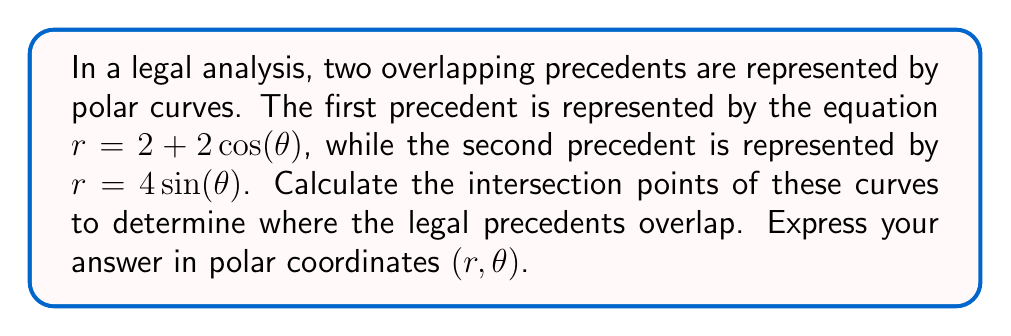Help me with this question. To find the intersection points of these polar curves, we need to solve the system of equations:

$$r = 2 + 2\cos(\theta)$$
$$r = 4\sin(\theta)$$

Step 1: Set the equations equal to each other
$2 + 2\cos(\theta) = 4\sin(\theta)$

Step 2: Rearrange the equation
$2\cos(\theta) - 4\sin(\theta) = -2$

Step 3: Divide both sides by 2
$\cos(\theta) - 2\sin(\theta) = -1$

Step 4: Use the identity $\sin^2(\theta) + \cos^2(\theta) = 1$ to solve for $\sin(\theta)$ and $\cos(\theta)$

Let $\sin(\theta) = x$ and $\cos(\theta) = y$. Then our equation becomes:
$y - 2x = -1$ and $x^2 + y^2 = 1$

Step 5: Solve for y in terms of x
$y = 2x - 1$

Step 6: Substitute this into $x^2 + y^2 = 1$
$x^2 + (2x - 1)^2 = 1$

Step 7: Expand and simplify
$x^2 + 4x^2 - 4x + 1 = 1$
$5x^2 - 4x = 0$
$x(5x - 4) = 0$

Step 8: Solve for x
$x = 0$ or $x = \frac{4}{5}$

Step 9: Find corresponding y values
For $x = 0$: $y = -1$
For $x = \frac{4}{5}$: $y = \frac{3}{5}$

Step 10: Convert back to $\theta$ values
$\theta_1 = \arctan(\frac{0}{-1}) + \pi = \pi$
$\theta_2 = \arctan(\frac{4/5}{3/5}) = \arctan(\frac{4}{3}) \approx 0.9273$ radians

Step 11: Calculate r values
For $\theta_1 = \pi$: $r = 2 + 2\cos(\pi) = 0$
For $\theta_2 \approx 0.9273$: $r = 4\sin(0.9273) \approx 3.2$

Therefore, the intersection points are $(0, \pi)$ and $(3.2, 0.9273)$ in polar coordinates $(r, \theta)$.
Answer: The intersection points of the polar curves representing the overlapping legal precedents are $(0, \pi)$ and $(3.2, 0.9273)$ in polar coordinates $(r, \theta)$. 